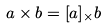Convert formula to latex. <formula><loc_0><loc_0><loc_500><loc_500>a \times b = [ a ] _ { \times } b</formula> 